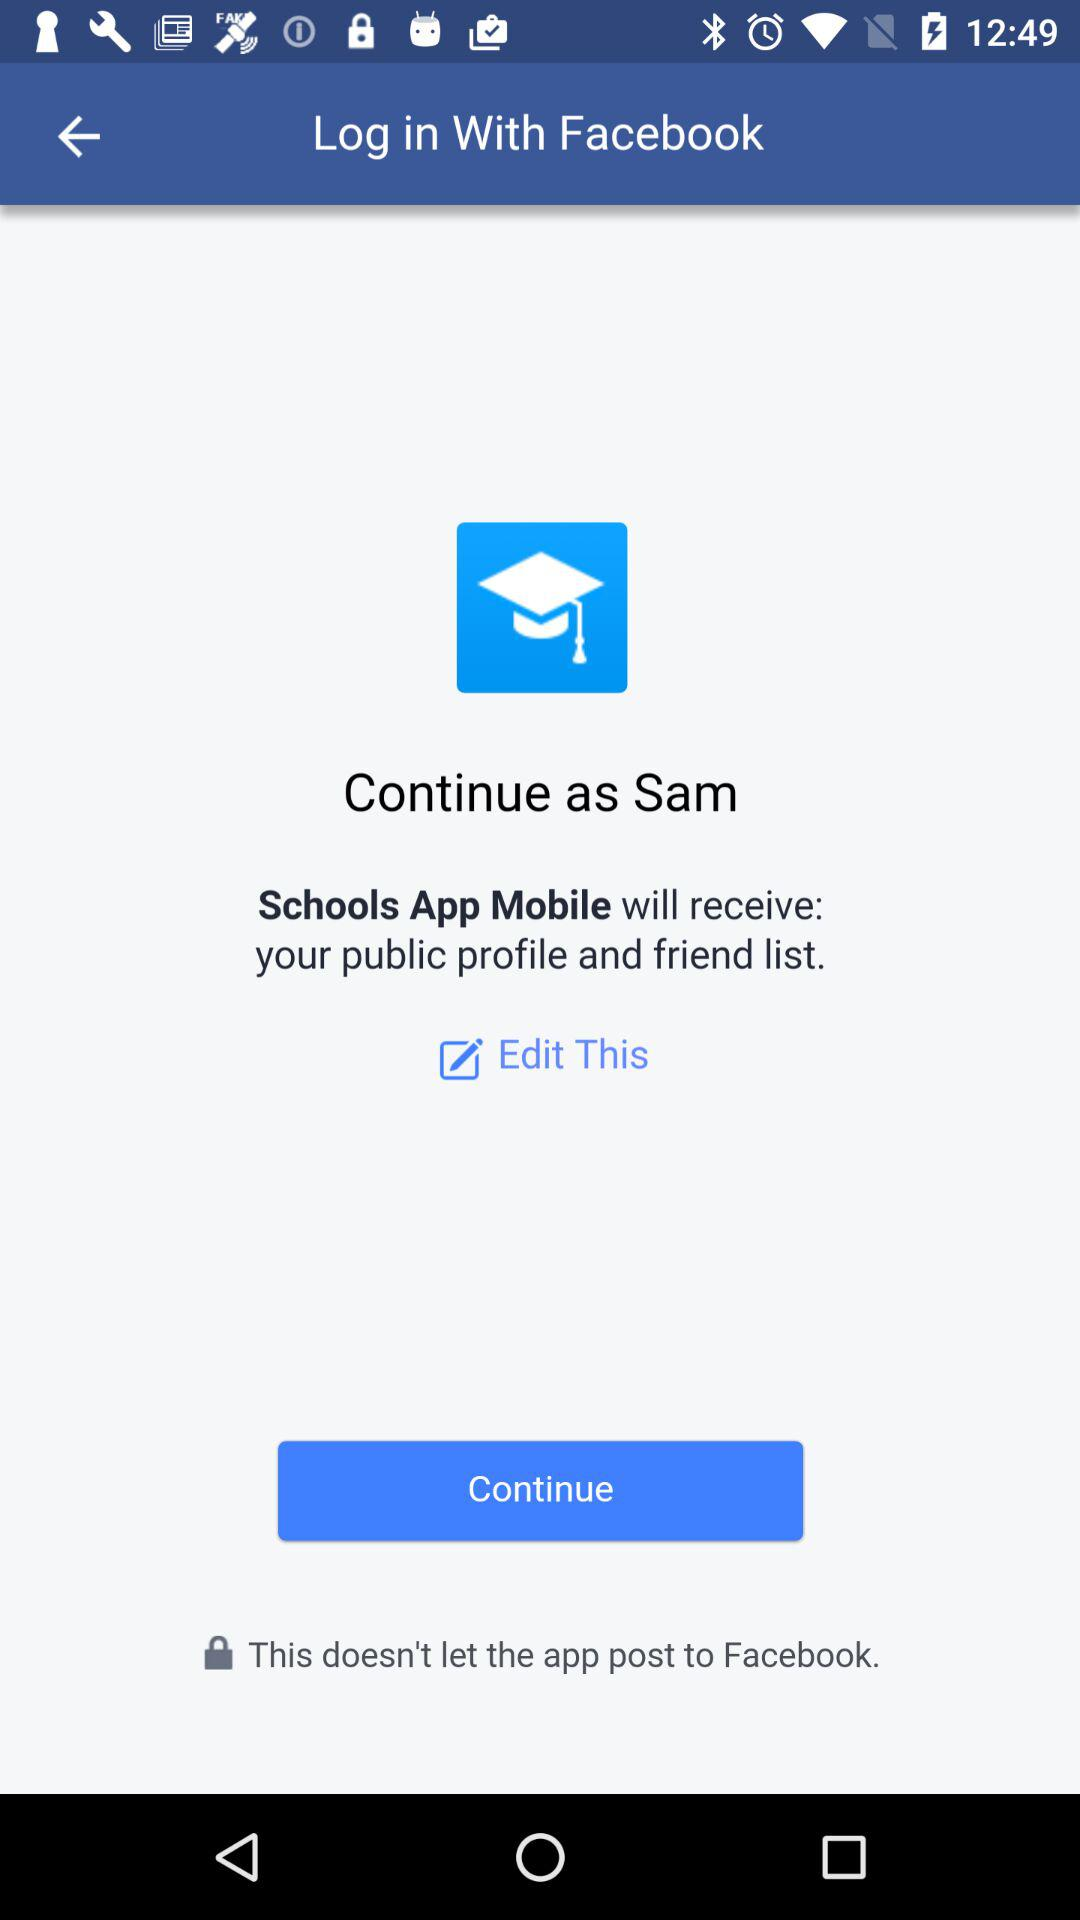What is the user's surname?
When the provided information is insufficient, respond with <no answer>. <no answer> 